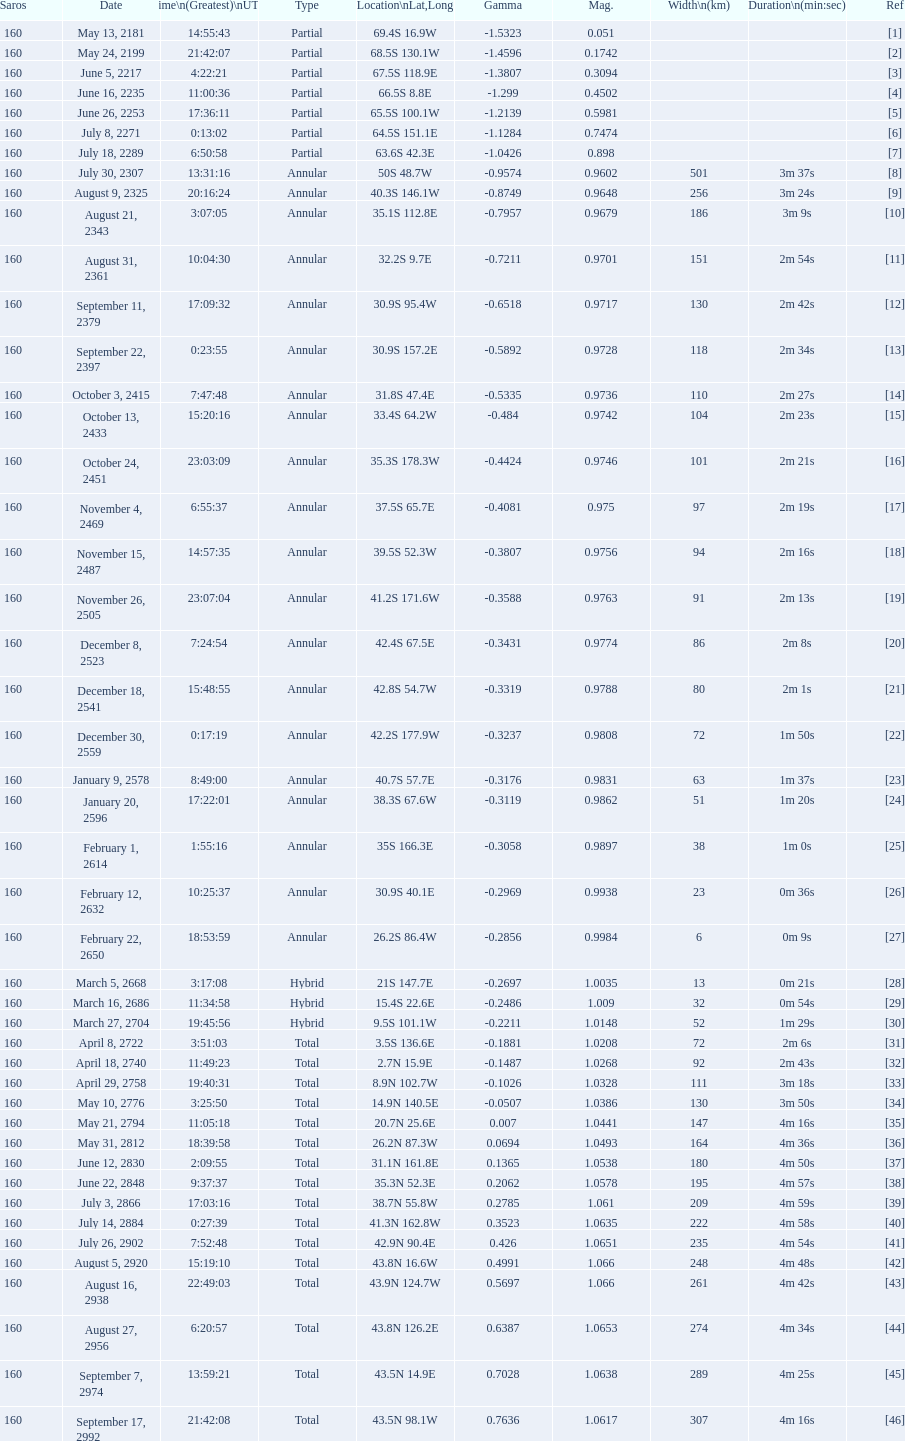Between 8 and 21, which one possesses a larger width? 8. 